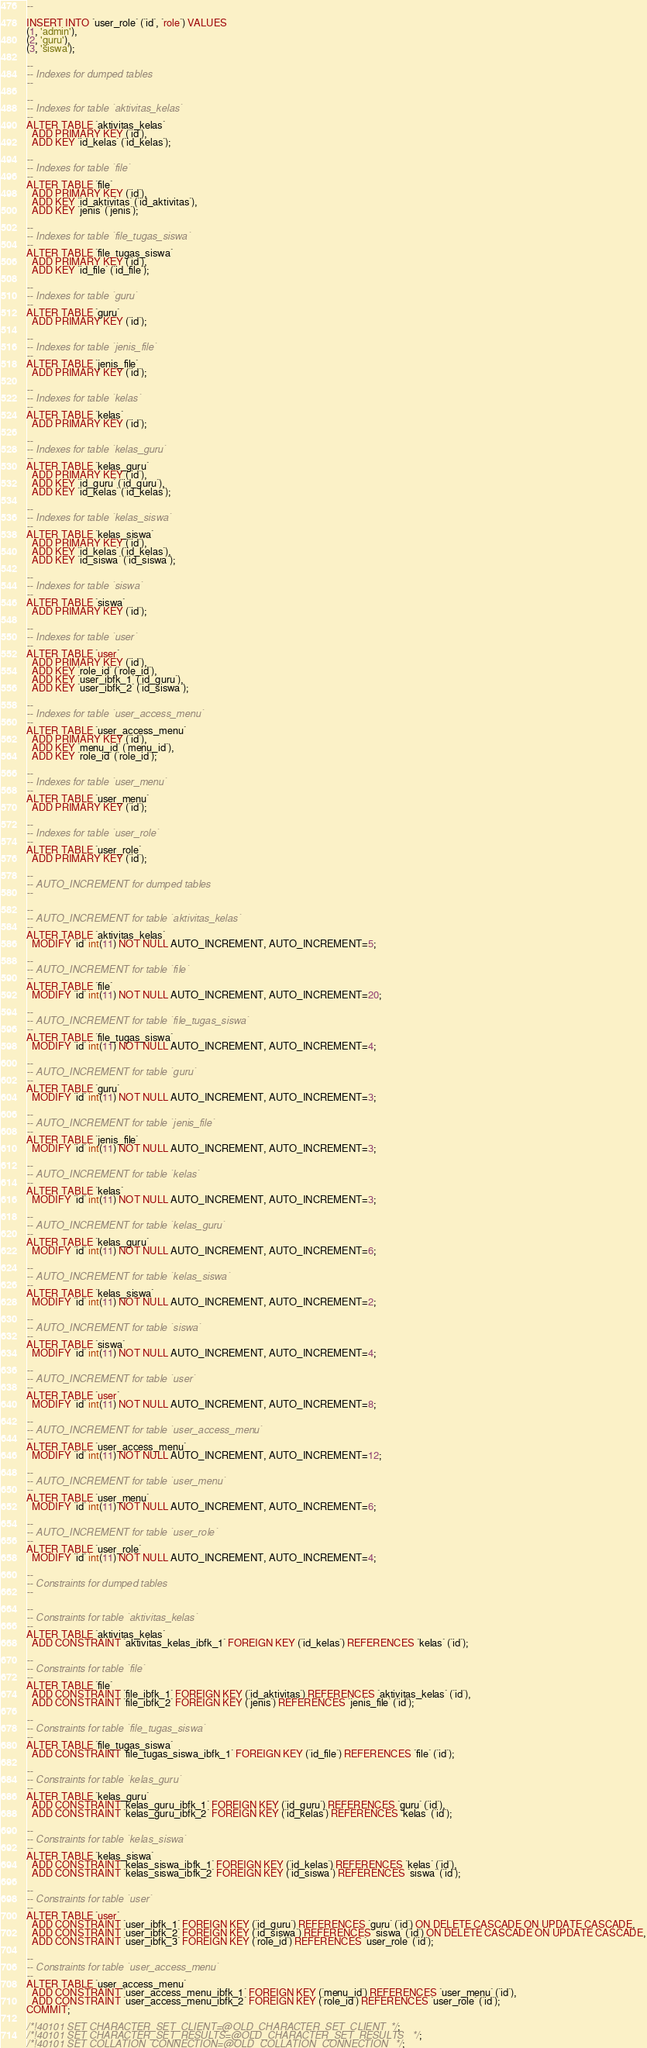Convert code to text. <code><loc_0><loc_0><loc_500><loc_500><_SQL_>--

INSERT INTO `user_role` (`id`, `role`) VALUES
(1, 'admin'),
(2, 'guru'),
(3, 'siswa');

--
-- Indexes for dumped tables
--

--
-- Indexes for table `aktivitas_kelas`
--
ALTER TABLE `aktivitas_kelas`
  ADD PRIMARY KEY (`id`),
  ADD KEY `id_kelas` (`id_kelas`);

--
-- Indexes for table `file`
--
ALTER TABLE `file`
  ADD PRIMARY KEY (`id`),
  ADD KEY `id_aktivitas` (`id_aktivitas`),
  ADD KEY `jenis` (`jenis`);

--
-- Indexes for table `file_tugas_siswa`
--
ALTER TABLE `file_tugas_siswa`
  ADD PRIMARY KEY (`id`),
  ADD KEY `id_file` (`id_file`);

--
-- Indexes for table `guru`
--
ALTER TABLE `guru`
  ADD PRIMARY KEY (`id`);

--
-- Indexes for table `jenis_file`
--
ALTER TABLE `jenis_file`
  ADD PRIMARY KEY (`id`);

--
-- Indexes for table `kelas`
--
ALTER TABLE `kelas`
  ADD PRIMARY KEY (`id`);

--
-- Indexes for table `kelas_guru`
--
ALTER TABLE `kelas_guru`
  ADD PRIMARY KEY (`id`),
  ADD KEY `id_guru` (`id_guru`),
  ADD KEY `id_kelas` (`id_kelas`);

--
-- Indexes for table `kelas_siswa`
--
ALTER TABLE `kelas_siswa`
  ADD PRIMARY KEY (`id`),
  ADD KEY `id_kelas` (`id_kelas`),
  ADD KEY `id_siswa` (`id_siswa`);

--
-- Indexes for table `siswa`
--
ALTER TABLE `siswa`
  ADD PRIMARY KEY (`id`);

--
-- Indexes for table `user`
--
ALTER TABLE `user`
  ADD PRIMARY KEY (`id`),
  ADD KEY `role_id` (`role_id`),
  ADD KEY `user_ibfk_1` (`id_guru`),
  ADD KEY `user_ibfk_2` (`id_siswa`);

--
-- Indexes for table `user_access_menu`
--
ALTER TABLE `user_access_menu`
  ADD PRIMARY KEY (`id`),
  ADD KEY `menu_id` (`menu_id`),
  ADD KEY `role_id` (`role_id`);

--
-- Indexes for table `user_menu`
--
ALTER TABLE `user_menu`
  ADD PRIMARY KEY (`id`);

--
-- Indexes for table `user_role`
--
ALTER TABLE `user_role`
  ADD PRIMARY KEY (`id`);

--
-- AUTO_INCREMENT for dumped tables
--

--
-- AUTO_INCREMENT for table `aktivitas_kelas`
--
ALTER TABLE `aktivitas_kelas`
  MODIFY `id` int(11) NOT NULL AUTO_INCREMENT, AUTO_INCREMENT=5;

--
-- AUTO_INCREMENT for table `file`
--
ALTER TABLE `file`
  MODIFY `id` int(11) NOT NULL AUTO_INCREMENT, AUTO_INCREMENT=20;

--
-- AUTO_INCREMENT for table `file_tugas_siswa`
--
ALTER TABLE `file_tugas_siswa`
  MODIFY `id` int(11) NOT NULL AUTO_INCREMENT, AUTO_INCREMENT=4;

--
-- AUTO_INCREMENT for table `guru`
--
ALTER TABLE `guru`
  MODIFY `id` int(11) NOT NULL AUTO_INCREMENT, AUTO_INCREMENT=3;

--
-- AUTO_INCREMENT for table `jenis_file`
--
ALTER TABLE `jenis_file`
  MODIFY `id` int(11) NOT NULL AUTO_INCREMENT, AUTO_INCREMENT=3;

--
-- AUTO_INCREMENT for table `kelas`
--
ALTER TABLE `kelas`
  MODIFY `id` int(11) NOT NULL AUTO_INCREMENT, AUTO_INCREMENT=3;

--
-- AUTO_INCREMENT for table `kelas_guru`
--
ALTER TABLE `kelas_guru`
  MODIFY `id` int(11) NOT NULL AUTO_INCREMENT, AUTO_INCREMENT=6;

--
-- AUTO_INCREMENT for table `kelas_siswa`
--
ALTER TABLE `kelas_siswa`
  MODIFY `id` int(11) NOT NULL AUTO_INCREMENT, AUTO_INCREMENT=2;

--
-- AUTO_INCREMENT for table `siswa`
--
ALTER TABLE `siswa`
  MODIFY `id` int(11) NOT NULL AUTO_INCREMENT, AUTO_INCREMENT=4;

--
-- AUTO_INCREMENT for table `user`
--
ALTER TABLE `user`
  MODIFY `id` int(11) NOT NULL AUTO_INCREMENT, AUTO_INCREMENT=8;

--
-- AUTO_INCREMENT for table `user_access_menu`
--
ALTER TABLE `user_access_menu`
  MODIFY `id` int(11) NOT NULL AUTO_INCREMENT, AUTO_INCREMENT=12;

--
-- AUTO_INCREMENT for table `user_menu`
--
ALTER TABLE `user_menu`
  MODIFY `id` int(11) NOT NULL AUTO_INCREMENT, AUTO_INCREMENT=6;

--
-- AUTO_INCREMENT for table `user_role`
--
ALTER TABLE `user_role`
  MODIFY `id` int(11) NOT NULL AUTO_INCREMENT, AUTO_INCREMENT=4;

--
-- Constraints for dumped tables
--

--
-- Constraints for table `aktivitas_kelas`
--
ALTER TABLE `aktivitas_kelas`
  ADD CONSTRAINT `aktivitas_kelas_ibfk_1` FOREIGN KEY (`id_kelas`) REFERENCES `kelas` (`id`);

--
-- Constraints for table `file`
--
ALTER TABLE `file`
  ADD CONSTRAINT `file_ibfk_1` FOREIGN KEY (`id_aktivitas`) REFERENCES `aktivitas_kelas` (`id`),
  ADD CONSTRAINT `file_ibfk_2` FOREIGN KEY (`jenis`) REFERENCES `jenis_file` (`id`);

--
-- Constraints for table `file_tugas_siswa`
--
ALTER TABLE `file_tugas_siswa`
  ADD CONSTRAINT `file_tugas_siswa_ibfk_1` FOREIGN KEY (`id_file`) REFERENCES `file` (`id`);

--
-- Constraints for table `kelas_guru`
--
ALTER TABLE `kelas_guru`
  ADD CONSTRAINT `kelas_guru_ibfk_1` FOREIGN KEY (`id_guru`) REFERENCES `guru` (`id`),
  ADD CONSTRAINT `kelas_guru_ibfk_2` FOREIGN KEY (`id_kelas`) REFERENCES `kelas` (`id`);

--
-- Constraints for table `kelas_siswa`
--
ALTER TABLE `kelas_siswa`
  ADD CONSTRAINT `kelas_siswa_ibfk_1` FOREIGN KEY (`id_kelas`) REFERENCES `kelas` (`id`),
  ADD CONSTRAINT `kelas_siswa_ibfk_2` FOREIGN KEY (`id_siswa`) REFERENCES `siswa` (`id`);

--
-- Constraints for table `user`
--
ALTER TABLE `user`
  ADD CONSTRAINT `user_ibfk_1` FOREIGN KEY (`id_guru`) REFERENCES `guru` (`id`) ON DELETE CASCADE ON UPDATE CASCADE,
  ADD CONSTRAINT `user_ibfk_2` FOREIGN KEY (`id_siswa`) REFERENCES `siswa` (`id`) ON DELETE CASCADE ON UPDATE CASCADE,
  ADD CONSTRAINT `user_ibfk_3` FOREIGN KEY (`role_id`) REFERENCES `user_role` (`id`);

--
-- Constraints for table `user_access_menu`
--
ALTER TABLE `user_access_menu`
  ADD CONSTRAINT `user_access_menu_ibfk_1` FOREIGN KEY (`menu_id`) REFERENCES `user_menu` (`id`),
  ADD CONSTRAINT `user_access_menu_ibfk_2` FOREIGN KEY (`role_id`) REFERENCES `user_role` (`id`);
COMMIT;

/*!40101 SET CHARACTER_SET_CLIENT=@OLD_CHARACTER_SET_CLIENT */;
/*!40101 SET CHARACTER_SET_RESULTS=@OLD_CHARACTER_SET_RESULTS */;
/*!40101 SET COLLATION_CONNECTION=@OLD_COLLATION_CONNECTION */;
</code> 